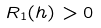Convert formula to latex. <formula><loc_0><loc_0><loc_500><loc_500>R _ { 1 } ( h ) > 0</formula> 